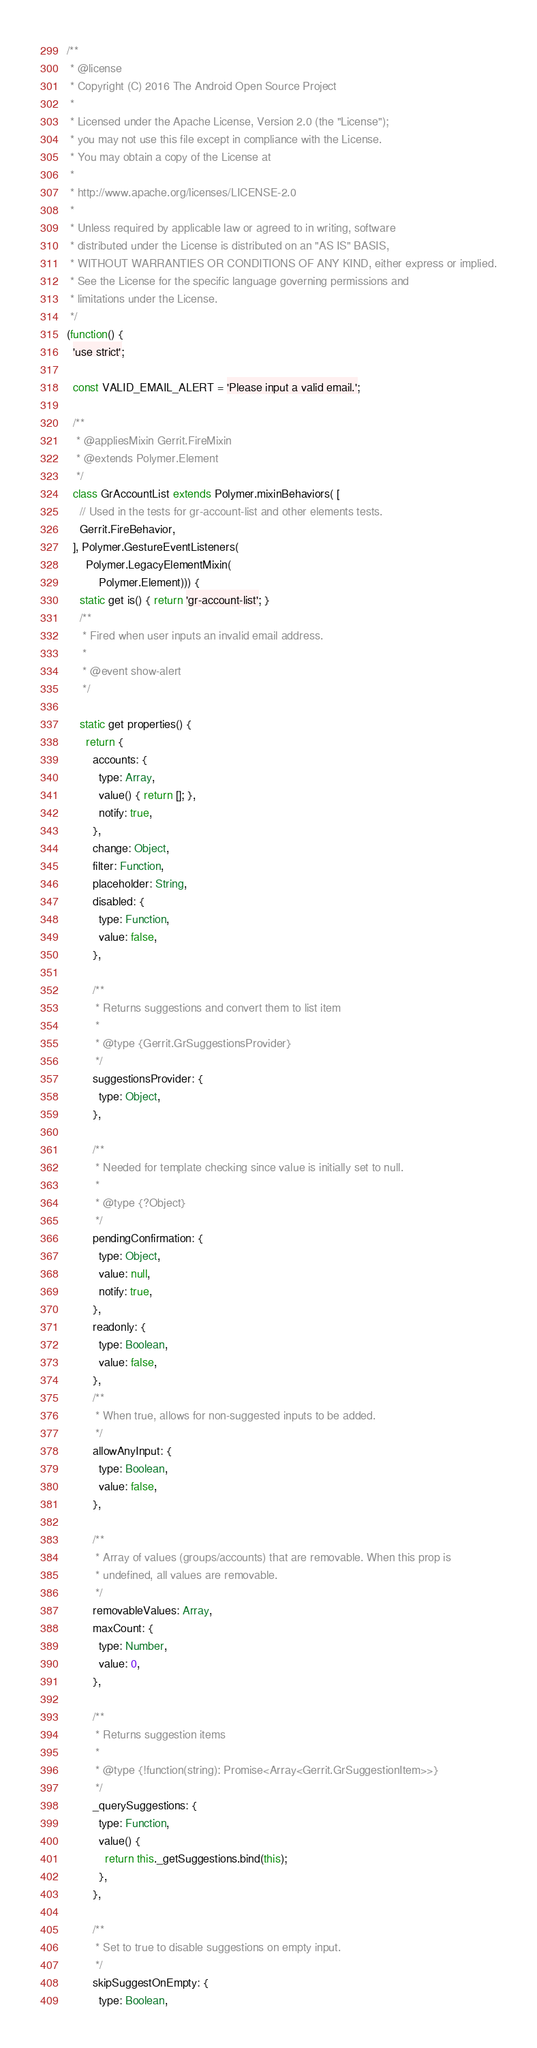Convert code to text. <code><loc_0><loc_0><loc_500><loc_500><_JavaScript_>/**
 * @license
 * Copyright (C) 2016 The Android Open Source Project
 *
 * Licensed under the Apache License, Version 2.0 (the "License");
 * you may not use this file except in compliance with the License.
 * You may obtain a copy of the License at
 *
 * http://www.apache.org/licenses/LICENSE-2.0
 *
 * Unless required by applicable law or agreed to in writing, software
 * distributed under the License is distributed on an "AS IS" BASIS,
 * WITHOUT WARRANTIES OR CONDITIONS OF ANY KIND, either express or implied.
 * See the License for the specific language governing permissions and
 * limitations under the License.
 */
(function() {
  'use strict';

  const VALID_EMAIL_ALERT = 'Please input a valid email.';

  /**
   * @appliesMixin Gerrit.FireMixin
   * @extends Polymer.Element
   */
  class GrAccountList extends Polymer.mixinBehaviors( [
    // Used in the tests for gr-account-list and other elements tests.
    Gerrit.FireBehavior,
  ], Polymer.GestureEventListeners(
      Polymer.LegacyElementMixin(
          Polymer.Element))) {
    static get is() { return 'gr-account-list'; }
    /**
     * Fired when user inputs an invalid email address.
     *
     * @event show-alert
     */

    static get properties() {
      return {
        accounts: {
          type: Array,
          value() { return []; },
          notify: true,
        },
        change: Object,
        filter: Function,
        placeholder: String,
        disabled: {
          type: Function,
          value: false,
        },

        /**
         * Returns suggestions and convert them to list item
         *
         * @type {Gerrit.GrSuggestionsProvider}
         */
        suggestionsProvider: {
          type: Object,
        },

        /**
         * Needed for template checking since value is initially set to null.
         *
         * @type {?Object}
         */
        pendingConfirmation: {
          type: Object,
          value: null,
          notify: true,
        },
        readonly: {
          type: Boolean,
          value: false,
        },
        /**
         * When true, allows for non-suggested inputs to be added.
         */
        allowAnyInput: {
          type: Boolean,
          value: false,
        },

        /**
         * Array of values (groups/accounts) that are removable. When this prop is
         * undefined, all values are removable.
         */
        removableValues: Array,
        maxCount: {
          type: Number,
          value: 0,
        },

        /**
         * Returns suggestion items
         *
         * @type {!function(string): Promise<Array<Gerrit.GrSuggestionItem>>}
         */
        _querySuggestions: {
          type: Function,
          value() {
            return this._getSuggestions.bind(this);
          },
        },

        /**
         * Set to true to disable suggestions on empty input.
         */
        skipSuggestOnEmpty: {
          type: Boolean,</code> 